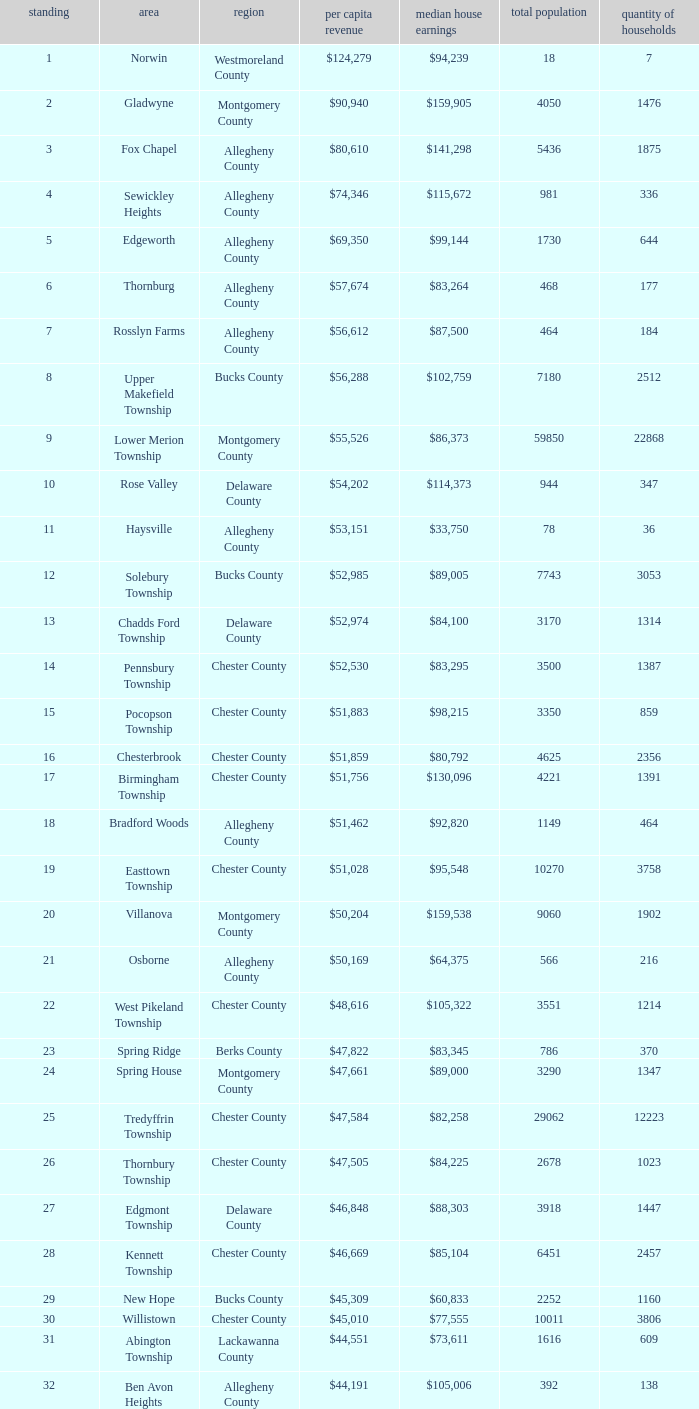Which county has a median household income of  $98,090? Bucks County. 